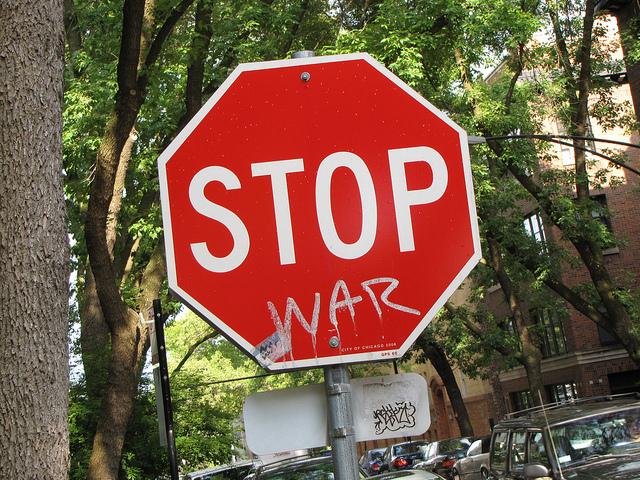What likely was used to write 'war'?
Be succinct. Spray paint. Was this photo taken in the middle of nowhere?
Give a very brief answer. No. What color is the stop sign?
Give a very brief answer. Red. 